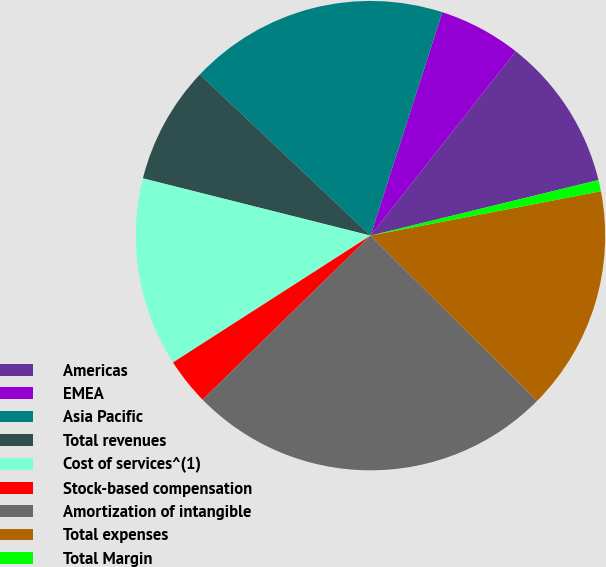<chart> <loc_0><loc_0><loc_500><loc_500><pie_chart><fcel>Americas<fcel>EMEA<fcel>Asia Pacific<fcel>Total revenues<fcel>Cost of services^(1)<fcel>Stock-based compensation<fcel>Amortization of intangible<fcel>Total expenses<fcel>Total Margin<nl><fcel>10.57%<fcel>5.67%<fcel>17.91%<fcel>8.12%<fcel>13.01%<fcel>3.23%<fcel>25.25%<fcel>15.46%<fcel>0.78%<nl></chart> 